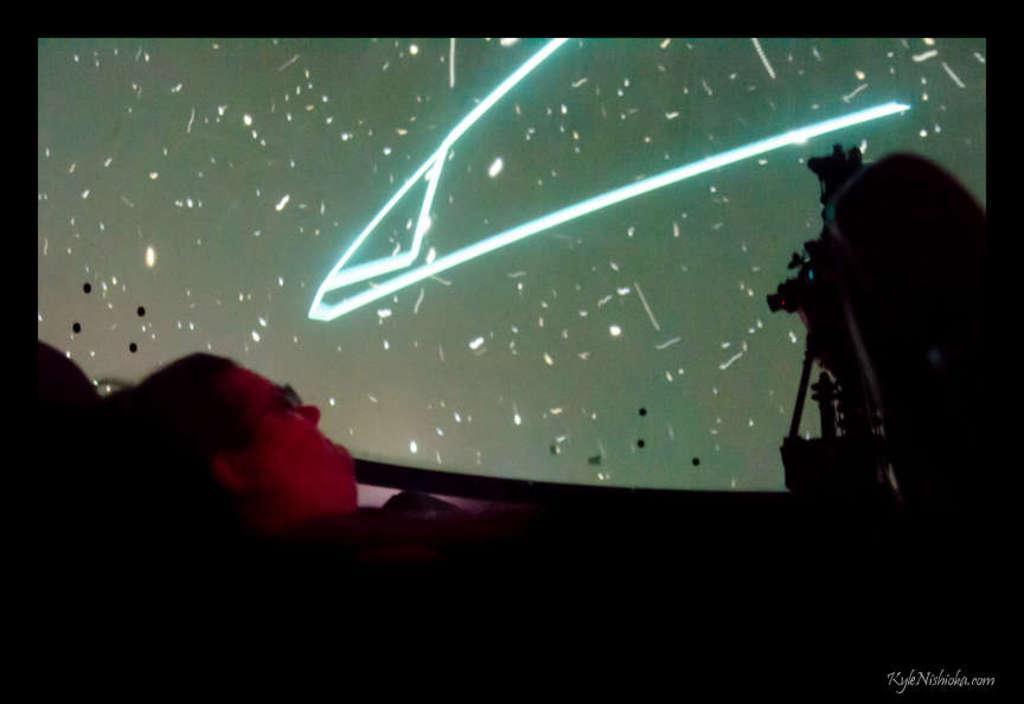Could you give a brief overview of what you see in this image? In this picture there is a man who is lying on the bed. In the background we can see the projector screen. On the right we can see camera and chairs. 